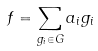<formula> <loc_0><loc_0><loc_500><loc_500>f = \sum _ { g _ { i } \in G } a _ { i } g _ { i }</formula> 